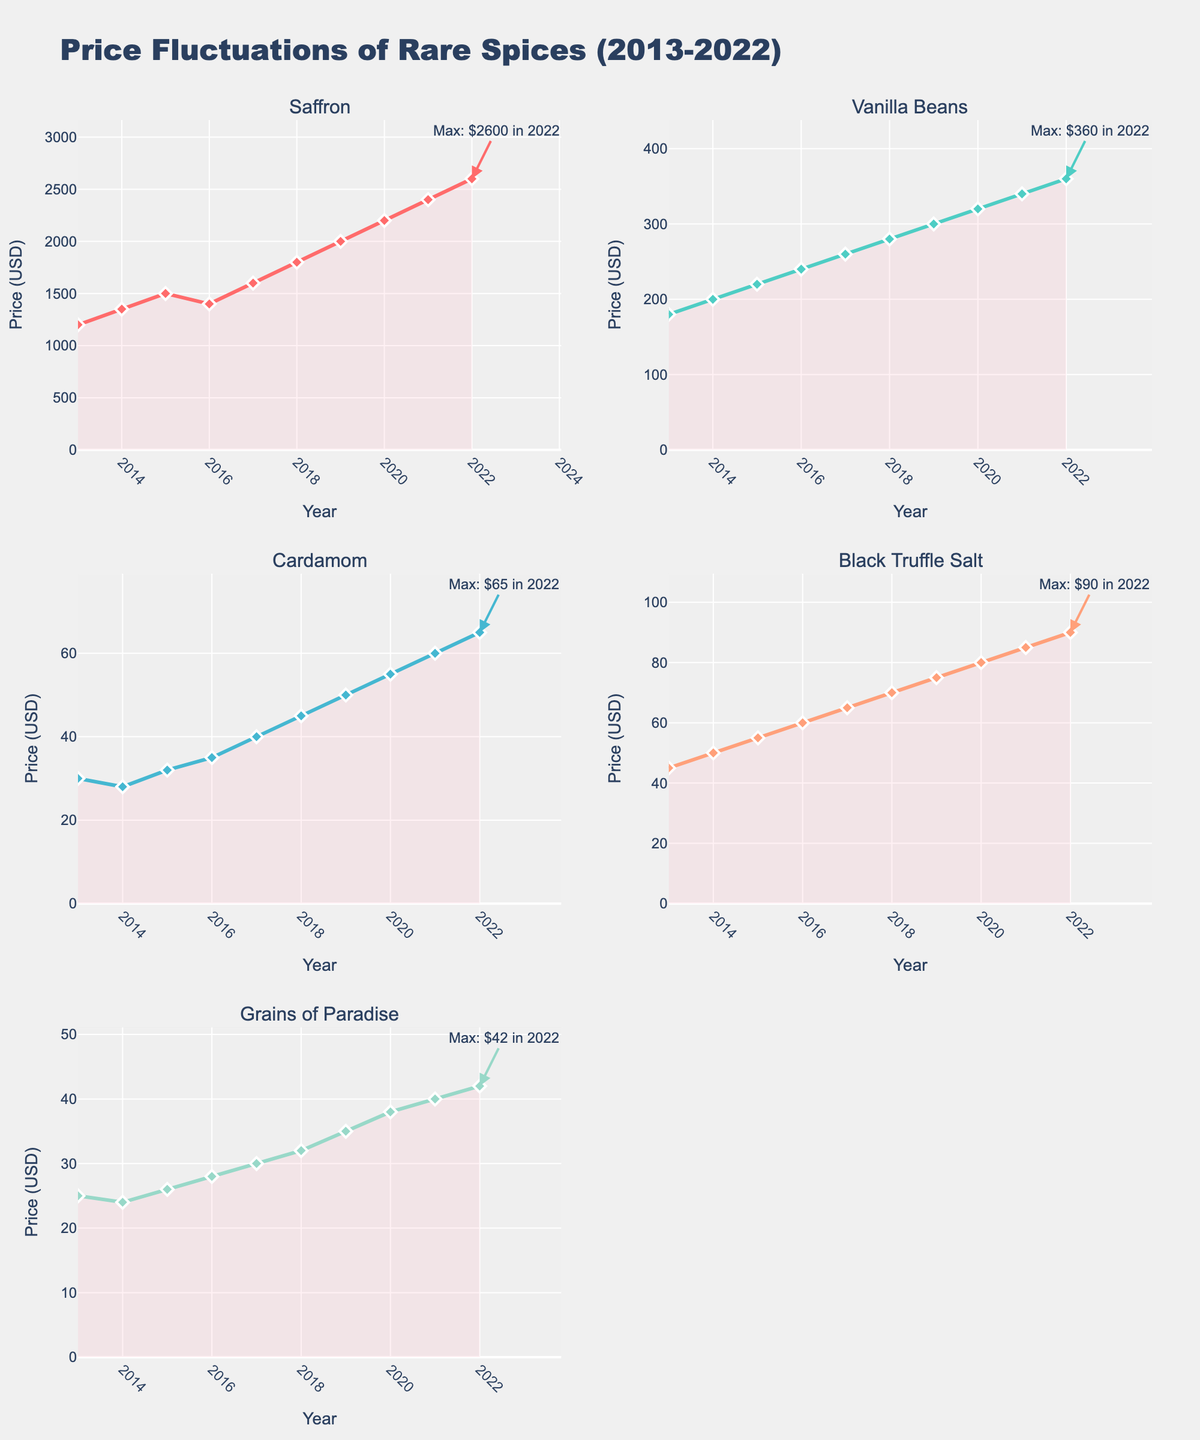Which spice experienced the highest price increase from 2013 to 2022? To determine the spice with the highest price increase, we subtract the 2013 price from the 2022 price for each spice. Saffron: 2600-1200 = 1400, Vanilla Beans: 360-180 = 180, Cardamom: 65-30 = 35, Black Truffle Salt: 90-45 = 45, Grains of Paradise: 42-25 = 17. Saffron has the highest price increase.
Answer: Saffron In which year did Vanilla Beans reach its maximum price, and what was that price? The annotation on the subplot for Vanilla Beans indicates the maximum price with an annotation. According to the figure, it reached its maximum price in 2022 at $360.
Answer: 2022, $360 What is the average price of Black Truffle Salt over the decade? To find the average price, sum all the yearly prices of Black Truffle Salt and divide by the number of years. Average = (45+50+55+60+65+70+75+80+85+90)/10 = 675/10 = 67.5
Answer: $67.5 Which spice's price remained the most stable over the decade? Stability can be observed by looking at the range of the price changes. Grains of Paradise shows the least variation, ranging from $25 in 2013 to $42 in 2022, which is a relatively small increase compared to other spices.
Answer: Grains of Paradise How much did the price of Cardamom change between 2021 and 2022? To calculate the change, subtract the 2021 price from the 2022 price. Change = 65 - 60 = 5
Answer: $5 Which two spices had the closest prices in 2015? Comparing the prices in 2015: Saffron: 1500, Vanilla Beans: 220, Cardamom: 32, Black Truffle Salt: 55, Grains of Paradise: 26. The closest prices are Cardamom ($32) and Grains of Paradise ($26), with a difference of $6.
Answer: Cardamom and Grains of Paradise What was the percentage increase in Saffron's price from 2019 to 2020? To determine the percentage increase, we use the formula: ((new price - old price) / old price) * 100. Increase = ((2200 - 2000) / 2000)*100 = 10%
Answer: 10% Between which consecutive years did Grains of Paradise experience the largest price change? To find this, we look at year-over-year changes for Grains of Paradise: 2013-2014: 24-25=-1, 2014-2015: 26-24=2, 2015-2016: 28-26=2, 2016-2017: 30-28=2, 2017-2018: 32-30=2, 2018-2019: 35-32=3, 2019-2020: 38-35=3, 2020-2021: 40-38=2, 2021-2022: 42-40=2. The largest change is 3 between both 2018-2019 and 2019-2020.
Answer: 2018-2019 and 2019-2020 Which spice had the highest price in 2018, and what was that price? To find this, compare the prices of all spices in 2018: Saffron: 1800, Vanilla Beans: 280, Cardamom: 45, Black Truffle Salt: 70, Grains of Paradise: 32. Saffron had the highest price at $1800.
Answer: Saffron, $1800 